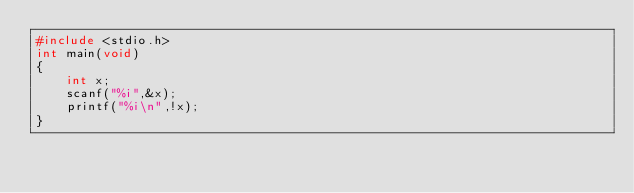<code> <loc_0><loc_0><loc_500><loc_500><_C_>#include <stdio.h>
int main(void)
{
    int x;
    scanf("%i",&x);
    printf("%i\n",!x);
}</code> 